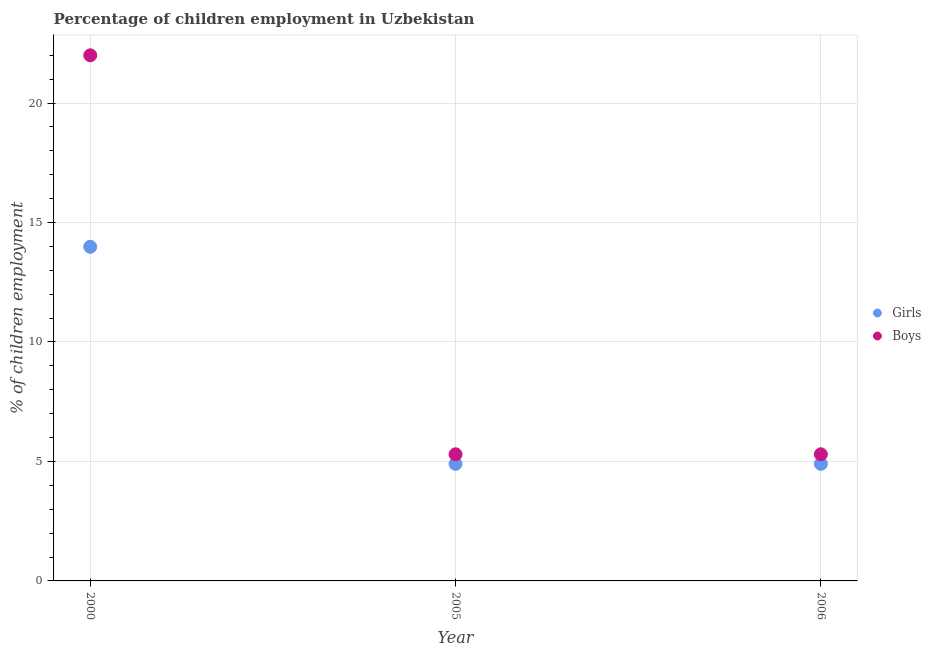How many different coloured dotlines are there?
Your answer should be very brief. 2. Across all years, what is the maximum percentage of employed girls?
Provide a succinct answer. 13.98. In which year was the percentage of employed girls minimum?
Your answer should be very brief. 2005. What is the total percentage of employed boys in the graph?
Give a very brief answer. 32.6. What is the difference between the percentage of employed boys in 2005 and that in 2006?
Your answer should be very brief. 0. What is the difference between the percentage of employed boys in 2000 and the percentage of employed girls in 2005?
Ensure brevity in your answer.  17.1. What is the average percentage of employed girls per year?
Ensure brevity in your answer.  7.93. In the year 2005, what is the difference between the percentage of employed girls and percentage of employed boys?
Give a very brief answer. -0.4. In how many years, is the percentage of employed girls greater than 9 %?
Make the answer very short. 1. What is the ratio of the percentage of employed boys in 2000 to that in 2006?
Offer a terse response. 4.15. Is the percentage of employed boys in 2005 less than that in 2006?
Give a very brief answer. No. What is the difference between the highest and the second highest percentage of employed boys?
Your answer should be compact. 16.7. What is the difference between the highest and the lowest percentage of employed boys?
Offer a very short reply. 16.7. In how many years, is the percentage of employed girls greater than the average percentage of employed girls taken over all years?
Offer a very short reply. 1. Is the sum of the percentage of employed girls in 2005 and 2006 greater than the maximum percentage of employed boys across all years?
Provide a short and direct response. No. Is the percentage of employed boys strictly less than the percentage of employed girls over the years?
Your answer should be very brief. No. How many dotlines are there?
Your answer should be very brief. 2. Are the values on the major ticks of Y-axis written in scientific E-notation?
Your answer should be very brief. No. Does the graph contain any zero values?
Make the answer very short. No. How many legend labels are there?
Offer a terse response. 2. What is the title of the graph?
Your response must be concise. Percentage of children employment in Uzbekistan. What is the label or title of the X-axis?
Give a very brief answer. Year. What is the label or title of the Y-axis?
Give a very brief answer. % of children employment. What is the % of children employment in Girls in 2000?
Ensure brevity in your answer.  13.98. What is the % of children employment in Boys in 2000?
Offer a very short reply. 22. What is the % of children employment of Girls in 2005?
Your response must be concise. 4.9. What is the % of children employment of Boys in 2005?
Provide a succinct answer. 5.3. Across all years, what is the maximum % of children employment in Girls?
Offer a very short reply. 13.98. Across all years, what is the maximum % of children employment of Boys?
Give a very brief answer. 22. Across all years, what is the minimum % of children employment of Girls?
Offer a terse response. 4.9. What is the total % of children employment of Girls in the graph?
Your response must be concise. 23.78. What is the total % of children employment in Boys in the graph?
Keep it short and to the point. 32.6. What is the difference between the % of children employment in Girls in 2000 and that in 2005?
Offer a very short reply. 9.08. What is the difference between the % of children employment of Boys in 2000 and that in 2005?
Your answer should be compact. 16.7. What is the difference between the % of children employment of Girls in 2000 and that in 2006?
Your answer should be compact. 9.08. What is the difference between the % of children employment in Boys in 2000 and that in 2006?
Offer a very short reply. 16.7. What is the difference between the % of children employment of Girls in 2005 and that in 2006?
Give a very brief answer. 0. What is the difference between the % of children employment of Boys in 2005 and that in 2006?
Your answer should be compact. 0. What is the difference between the % of children employment in Girls in 2000 and the % of children employment in Boys in 2005?
Ensure brevity in your answer.  8.68. What is the difference between the % of children employment of Girls in 2000 and the % of children employment of Boys in 2006?
Offer a terse response. 8.68. What is the average % of children employment in Girls per year?
Your response must be concise. 7.93. What is the average % of children employment of Boys per year?
Provide a short and direct response. 10.87. In the year 2000, what is the difference between the % of children employment of Girls and % of children employment of Boys?
Ensure brevity in your answer.  -8.02. In the year 2005, what is the difference between the % of children employment of Girls and % of children employment of Boys?
Provide a succinct answer. -0.4. What is the ratio of the % of children employment in Girls in 2000 to that in 2005?
Offer a very short reply. 2.85. What is the ratio of the % of children employment of Boys in 2000 to that in 2005?
Provide a succinct answer. 4.15. What is the ratio of the % of children employment of Girls in 2000 to that in 2006?
Offer a terse response. 2.85. What is the ratio of the % of children employment in Boys in 2000 to that in 2006?
Give a very brief answer. 4.15. What is the ratio of the % of children employment of Girls in 2005 to that in 2006?
Ensure brevity in your answer.  1. What is the ratio of the % of children employment of Boys in 2005 to that in 2006?
Your answer should be compact. 1. What is the difference between the highest and the second highest % of children employment in Girls?
Make the answer very short. 9.08. What is the difference between the highest and the second highest % of children employment in Boys?
Make the answer very short. 16.7. What is the difference between the highest and the lowest % of children employment in Girls?
Make the answer very short. 9.08. What is the difference between the highest and the lowest % of children employment of Boys?
Keep it short and to the point. 16.7. 